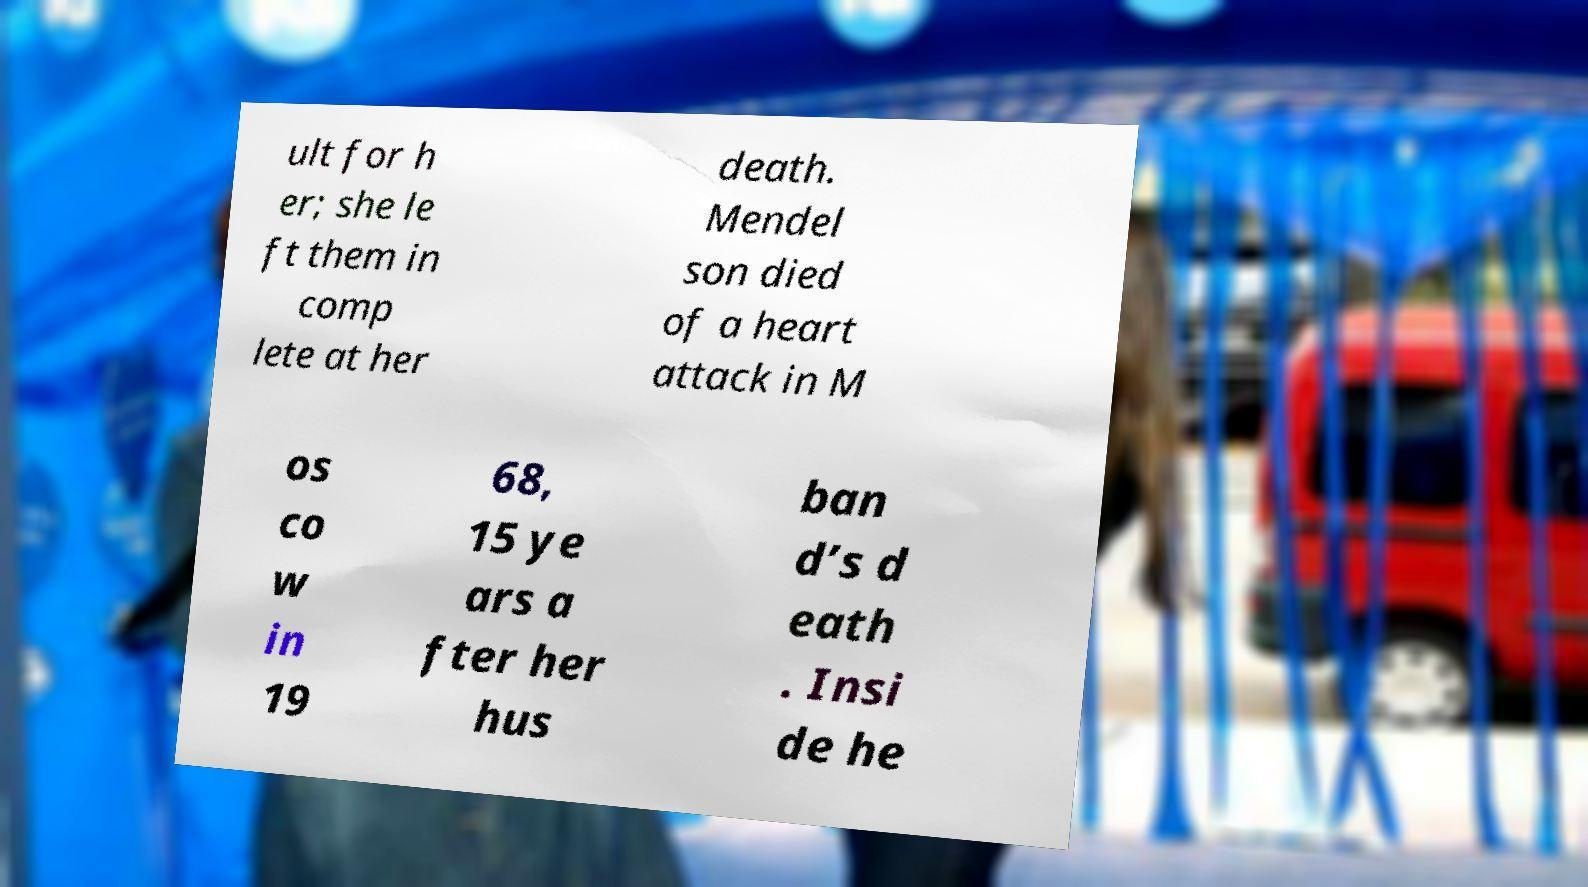Could you assist in decoding the text presented in this image and type it out clearly? ult for h er; she le ft them in comp lete at her death. Mendel son died of a heart attack in M os co w in 19 68, 15 ye ars a fter her hus ban d’s d eath . Insi de he 